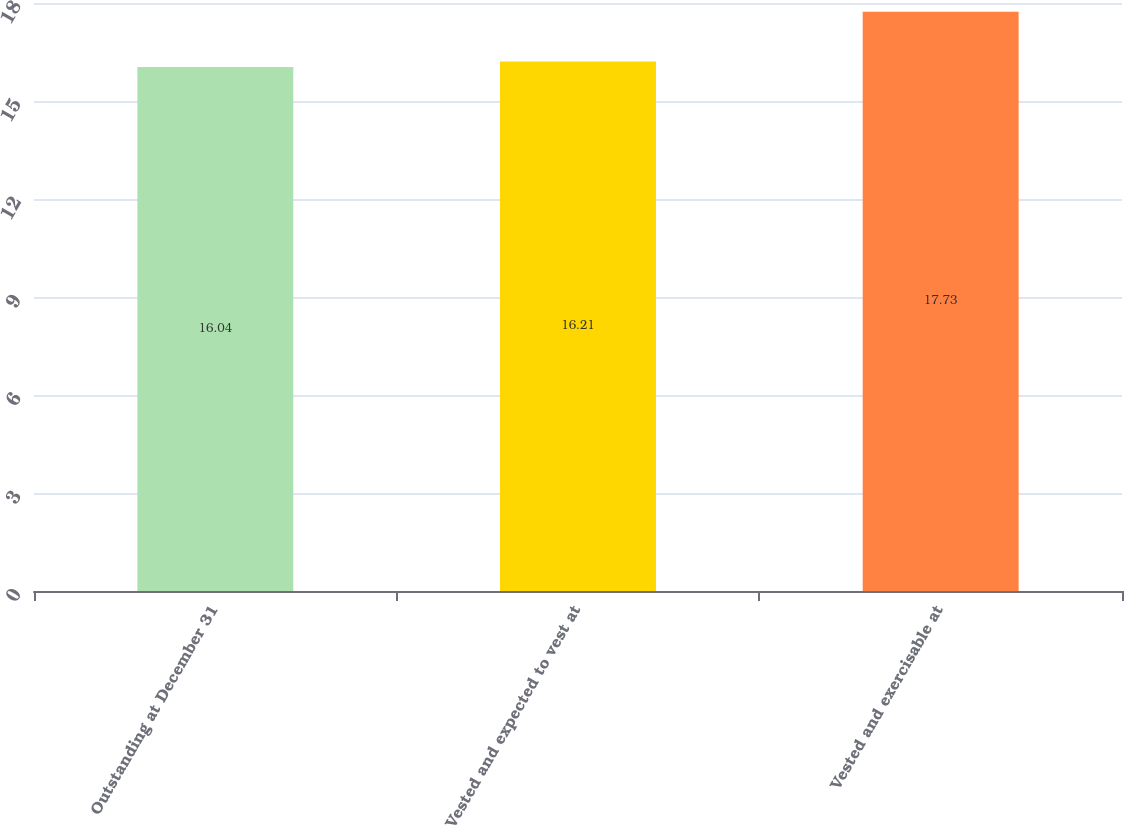Convert chart to OTSL. <chart><loc_0><loc_0><loc_500><loc_500><bar_chart><fcel>Outstanding at December 31<fcel>Vested and expected to vest at<fcel>Vested and exercisable at<nl><fcel>16.04<fcel>16.21<fcel>17.73<nl></chart> 